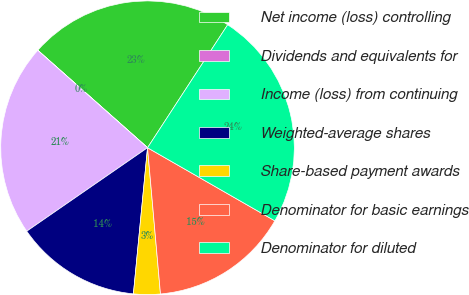<chart> <loc_0><loc_0><loc_500><loc_500><pie_chart><fcel>Net income (loss) controlling<fcel>Dividends and equivalents for<fcel>Income (loss) from continuing<fcel>Weighted-average shares<fcel>Share-based payment awards<fcel>Denominator for basic earnings<fcel>Denominator for diluted<nl><fcel>22.63%<fcel>0.01%<fcel>21.17%<fcel>13.84%<fcel>2.94%<fcel>15.3%<fcel>24.1%<nl></chart> 